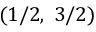<formula> <loc_0><loc_0><loc_500><loc_500>( 1 / 2 , \, 3 / 2 )</formula> 